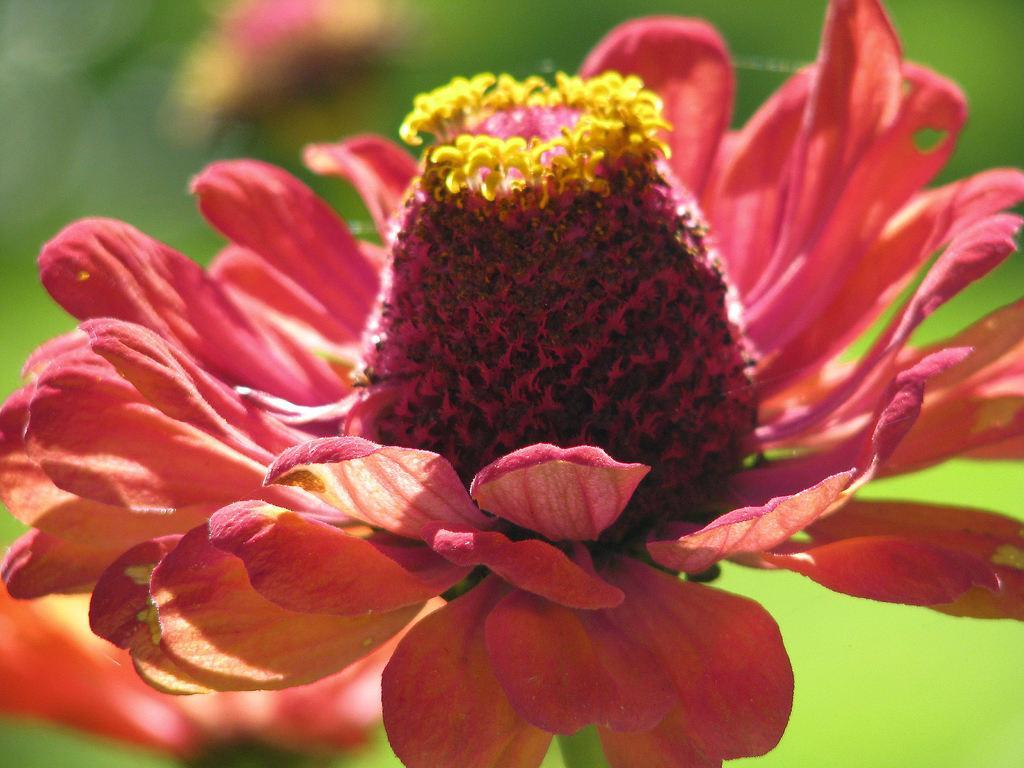In one or two sentences, can you explain what this image depicts? In this image there is a flower. In the center of the flower there are pollen grains. The background is blurry. 